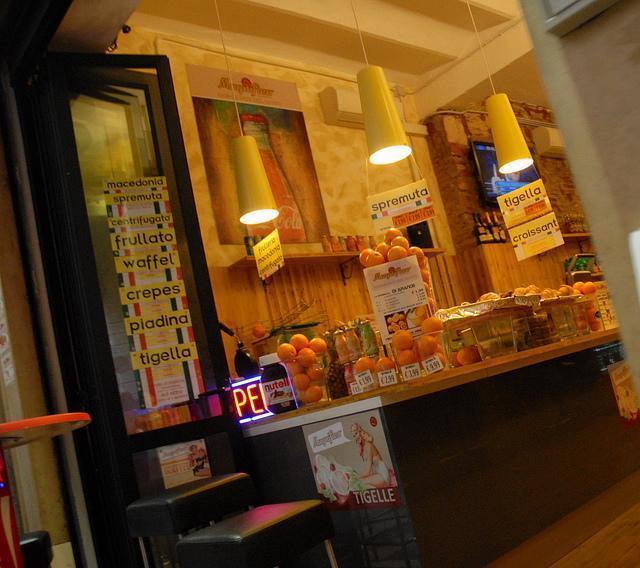How many different types of fruits are there?
Give a very brief answer. 1. How many street light are shown?
Give a very brief answer. 0. How many adult giraffes are in the image?
Give a very brief answer. 0. 